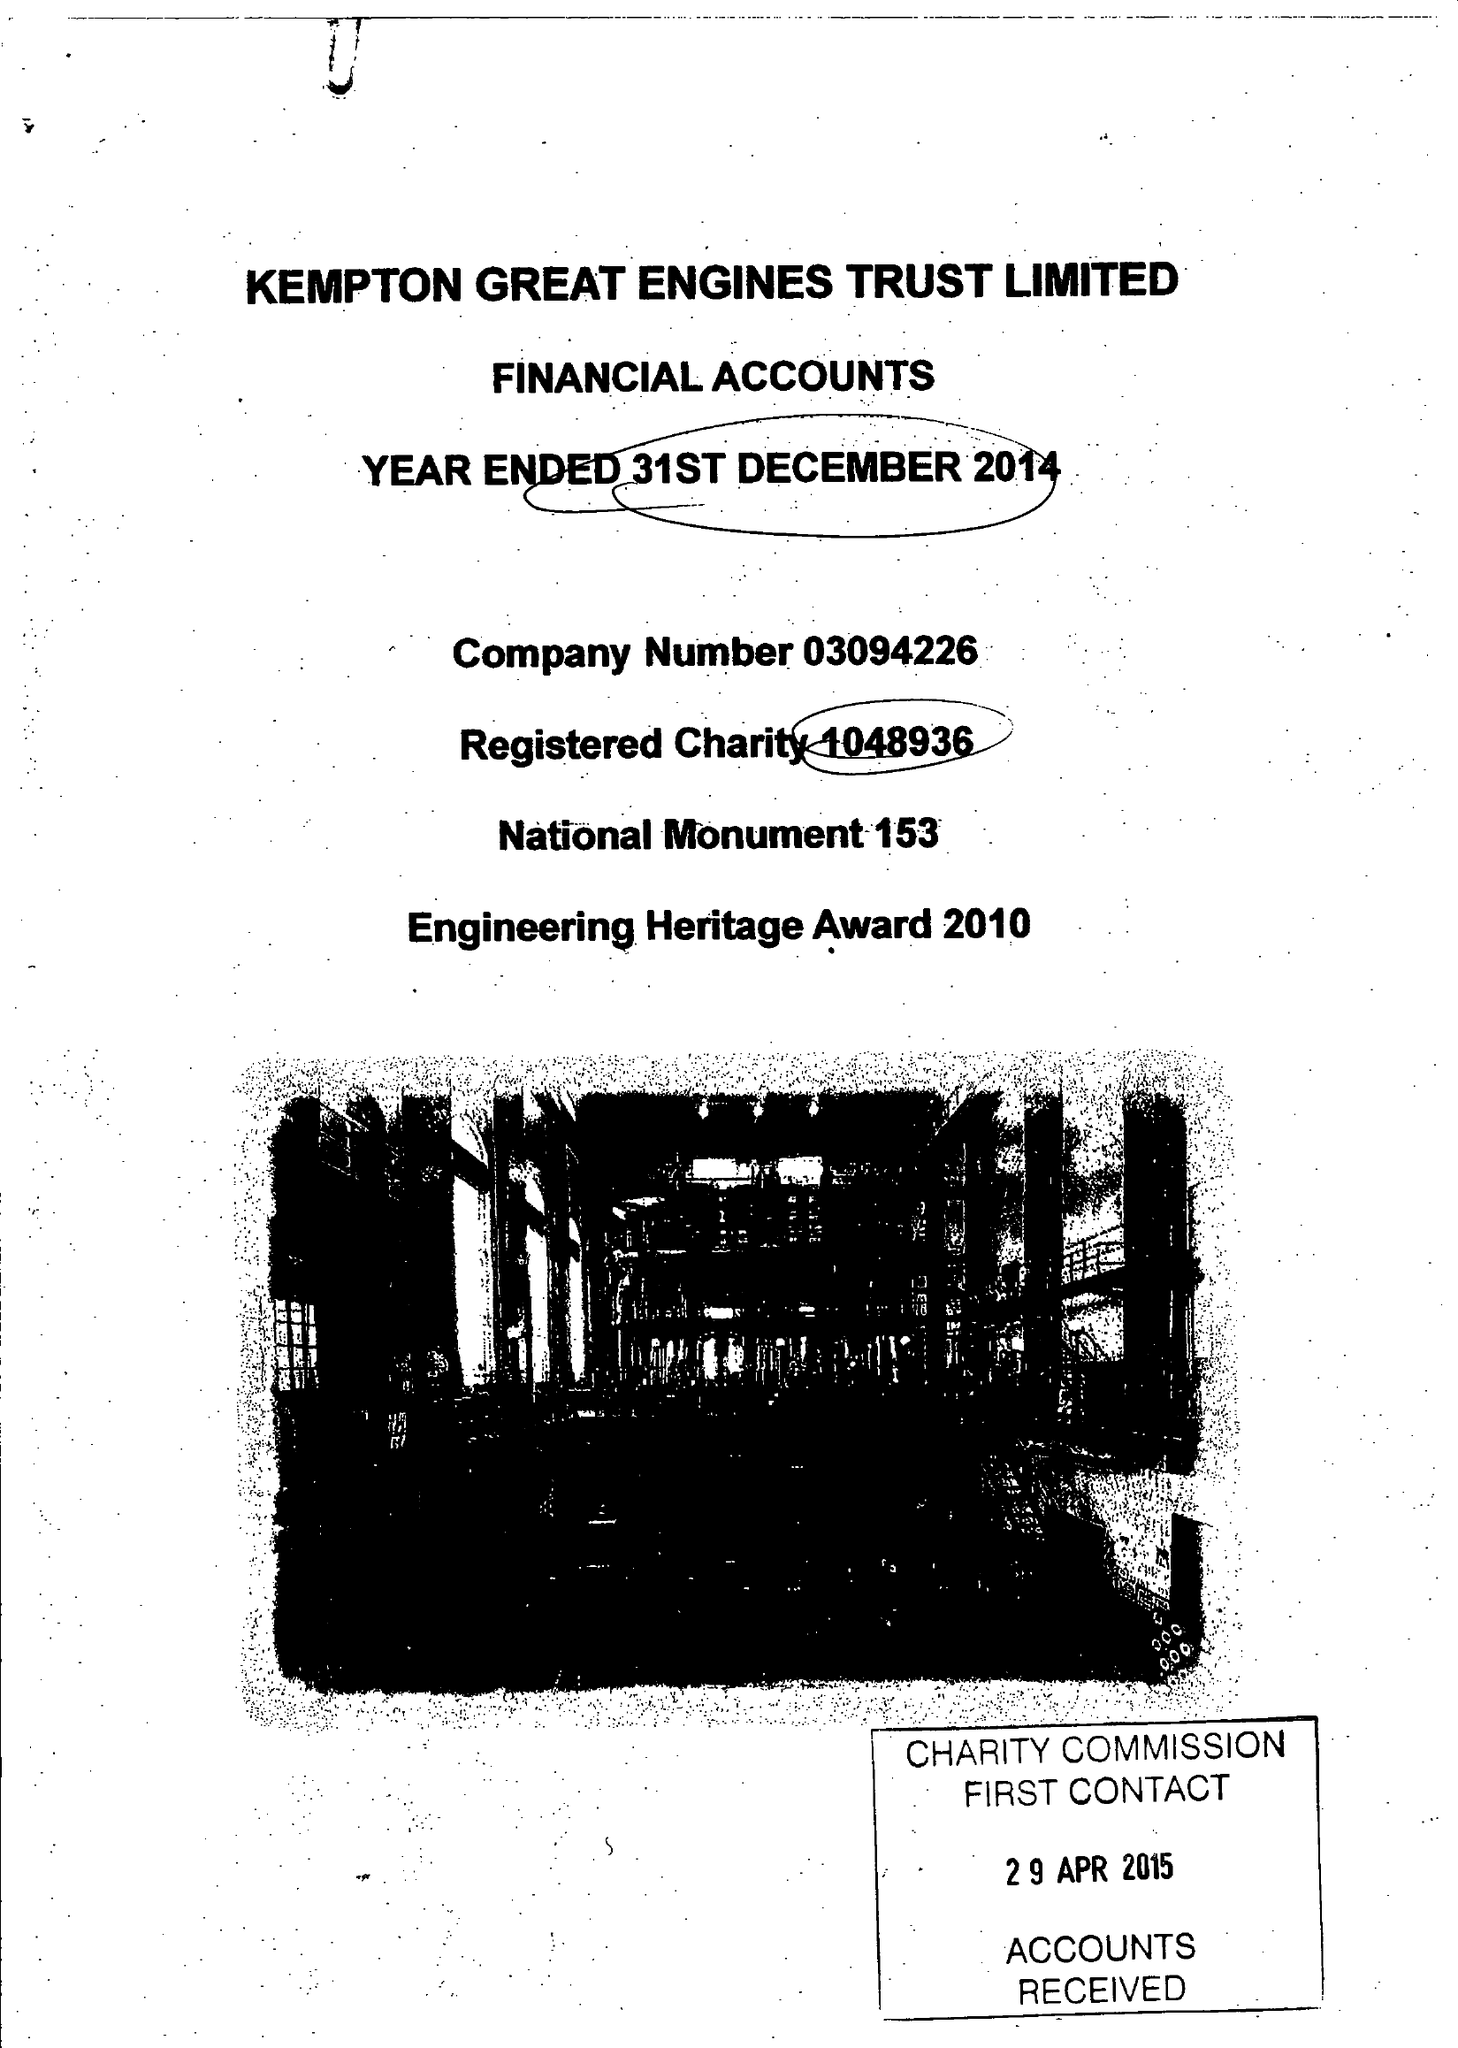What is the value for the address__street_line?
Answer the question using a single word or phrase. SNAKEY LANE 